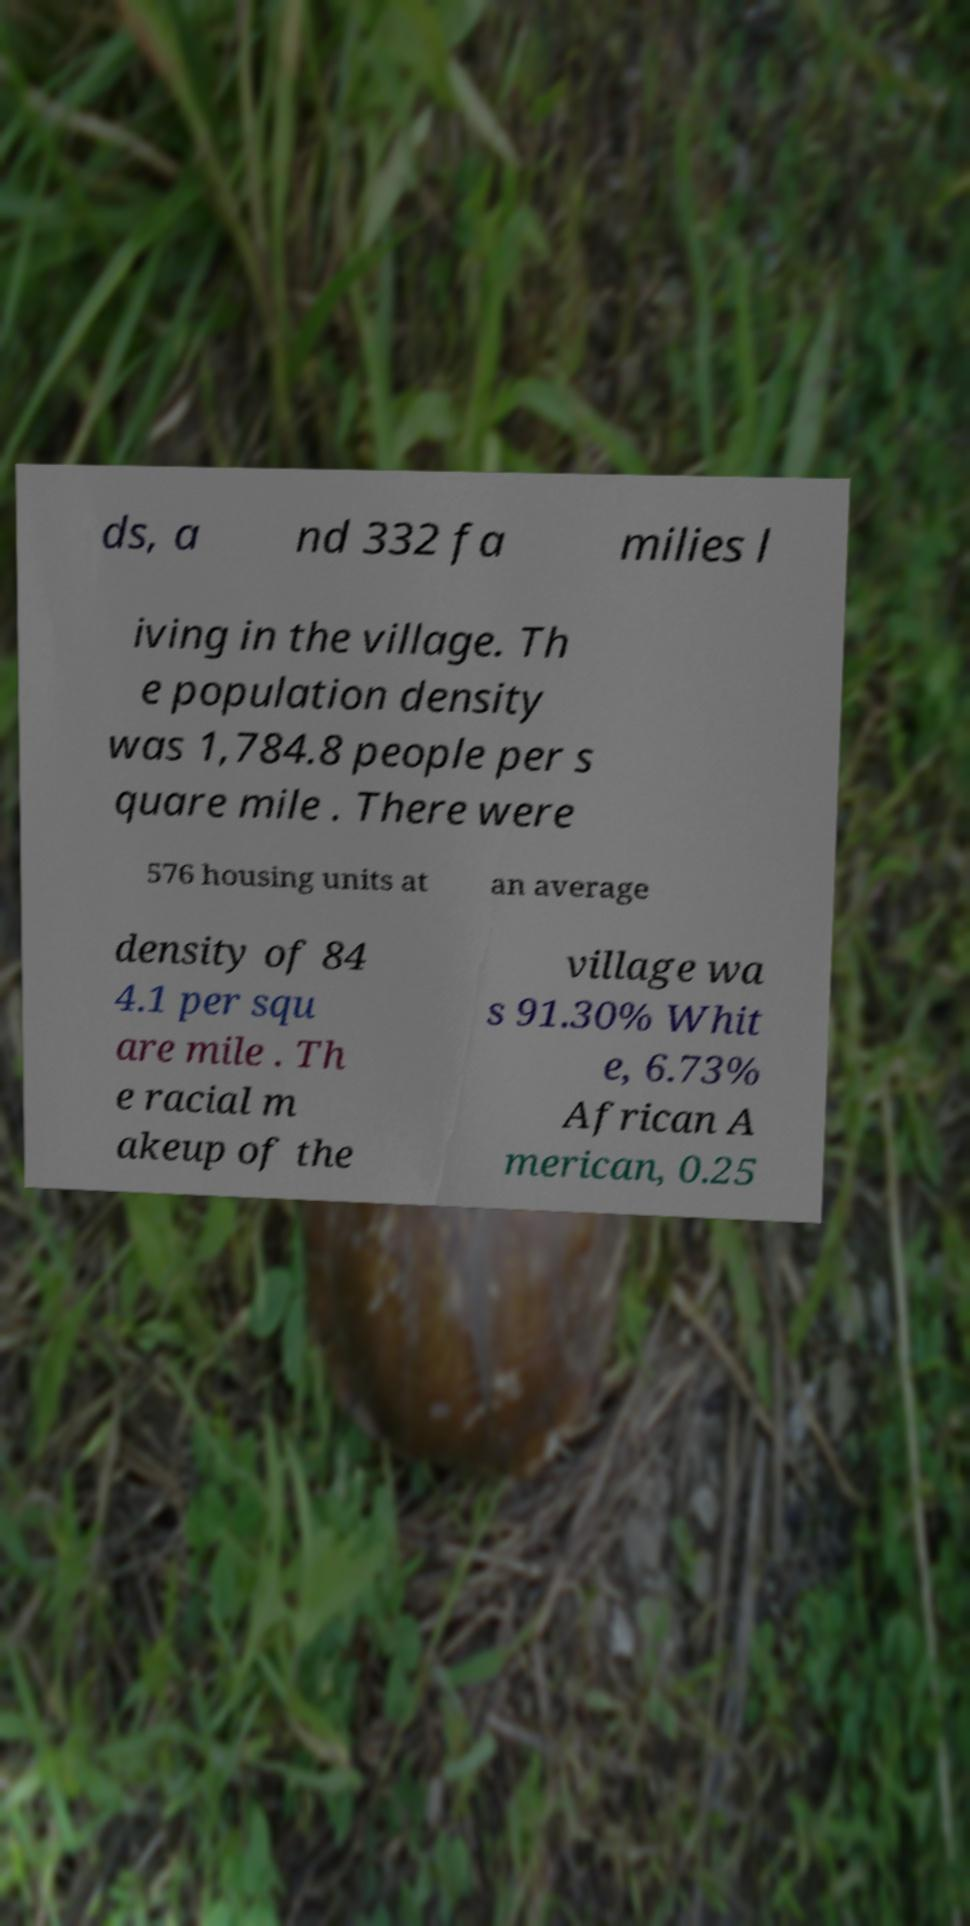There's text embedded in this image that I need extracted. Can you transcribe it verbatim? ds, a nd 332 fa milies l iving in the village. Th e population density was 1,784.8 people per s quare mile . There were 576 housing units at an average density of 84 4.1 per squ are mile . Th e racial m akeup of the village wa s 91.30% Whit e, 6.73% African A merican, 0.25 